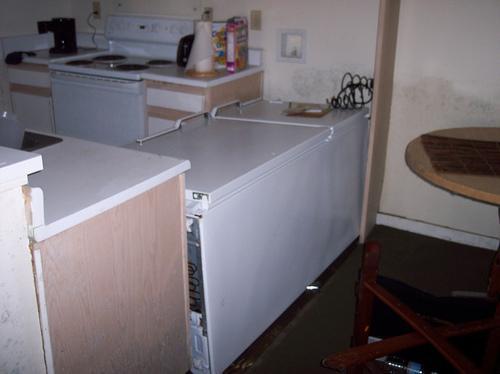How many electrical appliances are showing?
Give a very brief answer. 3. How many surfboards are behind the man?
Give a very brief answer. 0. 